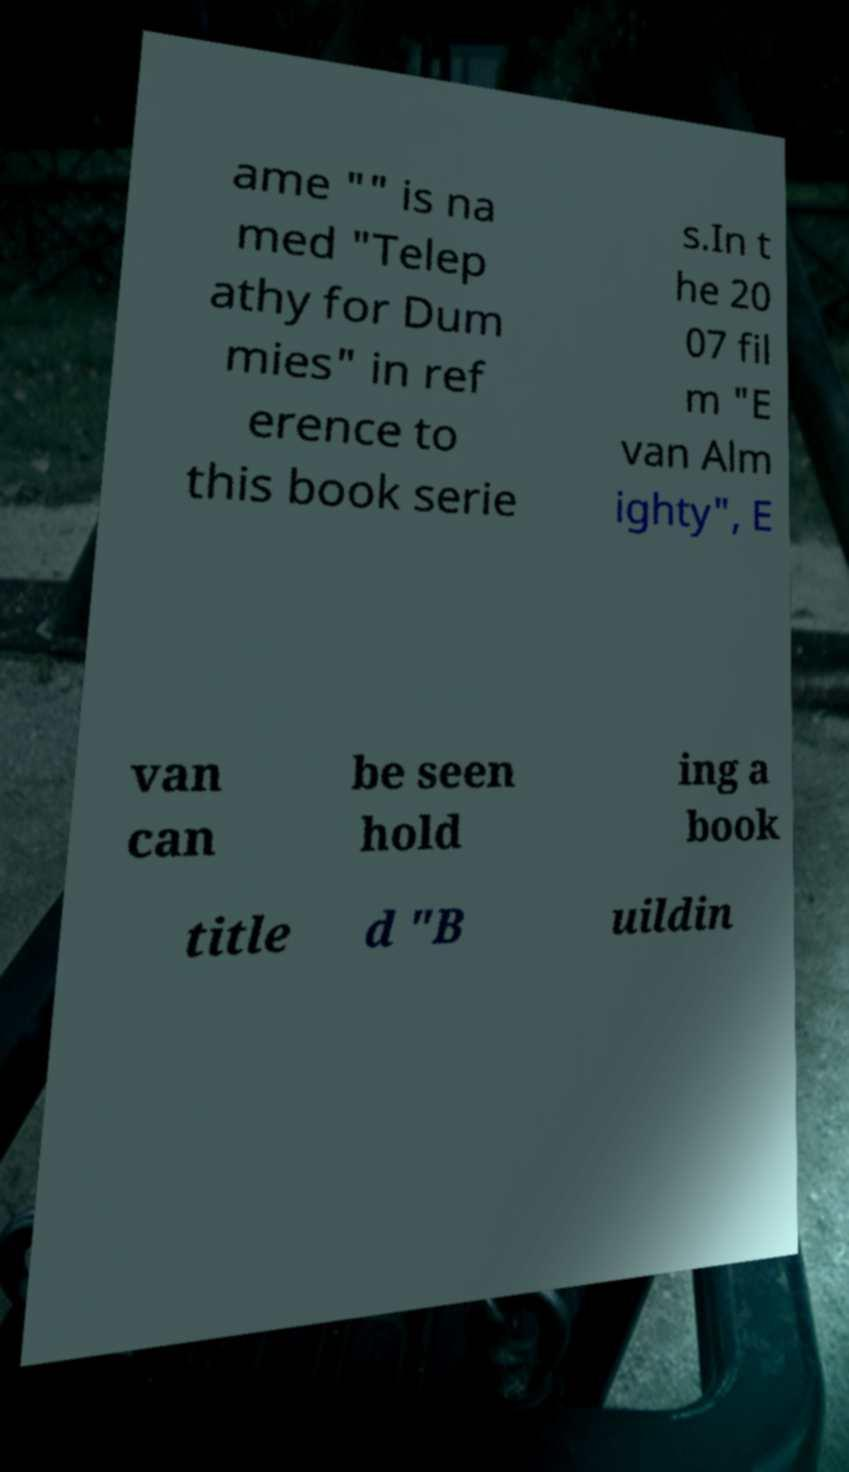What messages or text are displayed in this image? I need them in a readable, typed format. ame "" is na med "Telep athy for Dum mies" in ref erence to this book serie s.In t he 20 07 fil m "E van Alm ighty", E van can be seen hold ing a book title d "B uildin 